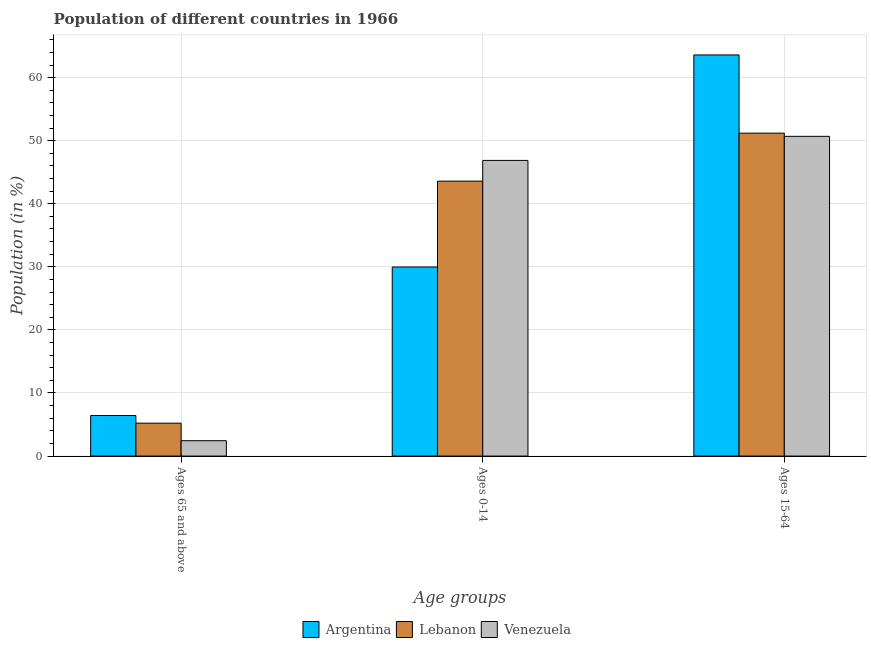How many different coloured bars are there?
Your answer should be very brief. 3. How many groups of bars are there?
Provide a succinct answer. 3. Are the number of bars per tick equal to the number of legend labels?
Give a very brief answer. Yes. What is the label of the 1st group of bars from the left?
Ensure brevity in your answer.  Ages 65 and above. What is the percentage of population within the age-group 0-14 in Venezuela?
Provide a succinct answer. 46.87. Across all countries, what is the maximum percentage of population within the age-group of 65 and above?
Your answer should be compact. 6.43. Across all countries, what is the minimum percentage of population within the age-group 0-14?
Your response must be concise. 29.98. In which country was the percentage of population within the age-group 15-64 minimum?
Your answer should be compact. Venezuela. What is the total percentage of population within the age-group of 65 and above in the graph?
Your answer should be very brief. 14.08. What is the difference between the percentage of population within the age-group of 65 and above in Argentina and that in Venezuela?
Offer a terse response. 3.99. What is the difference between the percentage of population within the age-group of 65 and above in Argentina and the percentage of population within the age-group 0-14 in Venezuela?
Ensure brevity in your answer.  -40.44. What is the average percentage of population within the age-group of 65 and above per country?
Ensure brevity in your answer.  4.69. What is the difference between the percentage of population within the age-group 15-64 and percentage of population within the age-group 0-14 in Argentina?
Your answer should be very brief. 33.62. In how many countries, is the percentage of population within the age-group 15-64 greater than 64 %?
Your answer should be very brief. 0. What is the ratio of the percentage of population within the age-group of 65 and above in Venezuela to that in Argentina?
Provide a succinct answer. 0.38. What is the difference between the highest and the second highest percentage of population within the age-group 0-14?
Ensure brevity in your answer.  3.29. What is the difference between the highest and the lowest percentage of population within the age-group of 65 and above?
Provide a succinct answer. 3.99. In how many countries, is the percentage of population within the age-group 15-64 greater than the average percentage of population within the age-group 15-64 taken over all countries?
Offer a terse response. 1. Is the sum of the percentage of population within the age-group 15-64 in Argentina and Lebanon greater than the maximum percentage of population within the age-group of 65 and above across all countries?
Give a very brief answer. Yes. What does the 2nd bar from the right in Ages 65 and above represents?
Offer a terse response. Lebanon. Are the values on the major ticks of Y-axis written in scientific E-notation?
Give a very brief answer. No. Where does the legend appear in the graph?
Provide a succinct answer. Bottom center. How many legend labels are there?
Your response must be concise. 3. How are the legend labels stacked?
Your response must be concise. Horizontal. What is the title of the graph?
Keep it short and to the point. Population of different countries in 1966. What is the label or title of the X-axis?
Your answer should be compact. Age groups. What is the label or title of the Y-axis?
Offer a very short reply. Population (in %). What is the Population (in %) in Argentina in Ages 65 and above?
Make the answer very short. 6.43. What is the Population (in %) in Lebanon in Ages 65 and above?
Make the answer very short. 5.22. What is the Population (in %) in Venezuela in Ages 65 and above?
Your response must be concise. 2.44. What is the Population (in %) in Argentina in Ages 0-14?
Your answer should be very brief. 29.98. What is the Population (in %) of Lebanon in Ages 0-14?
Provide a short and direct response. 43.59. What is the Population (in %) of Venezuela in Ages 0-14?
Your response must be concise. 46.87. What is the Population (in %) of Argentina in Ages 15-64?
Offer a very short reply. 63.6. What is the Population (in %) of Lebanon in Ages 15-64?
Provide a short and direct response. 51.2. What is the Population (in %) in Venezuela in Ages 15-64?
Make the answer very short. 50.69. Across all Age groups, what is the maximum Population (in %) in Argentina?
Ensure brevity in your answer.  63.6. Across all Age groups, what is the maximum Population (in %) in Lebanon?
Your response must be concise. 51.2. Across all Age groups, what is the maximum Population (in %) in Venezuela?
Your answer should be compact. 50.69. Across all Age groups, what is the minimum Population (in %) in Argentina?
Your answer should be very brief. 6.43. Across all Age groups, what is the minimum Population (in %) in Lebanon?
Your answer should be very brief. 5.22. Across all Age groups, what is the minimum Population (in %) of Venezuela?
Your response must be concise. 2.44. What is the total Population (in %) of Lebanon in the graph?
Your answer should be compact. 100. What is the total Population (in %) of Venezuela in the graph?
Provide a succinct answer. 100. What is the difference between the Population (in %) in Argentina in Ages 65 and above and that in Ages 0-14?
Offer a very short reply. -23.55. What is the difference between the Population (in %) of Lebanon in Ages 65 and above and that in Ages 0-14?
Ensure brevity in your answer.  -38.37. What is the difference between the Population (in %) of Venezuela in Ages 65 and above and that in Ages 0-14?
Make the answer very short. -44.44. What is the difference between the Population (in %) of Argentina in Ages 65 and above and that in Ages 15-64?
Your response must be concise. -57.17. What is the difference between the Population (in %) of Lebanon in Ages 65 and above and that in Ages 15-64?
Offer a very short reply. -45.98. What is the difference between the Population (in %) in Venezuela in Ages 65 and above and that in Ages 15-64?
Offer a very short reply. -48.25. What is the difference between the Population (in %) of Argentina in Ages 0-14 and that in Ages 15-64?
Offer a terse response. -33.62. What is the difference between the Population (in %) of Lebanon in Ages 0-14 and that in Ages 15-64?
Offer a terse response. -7.61. What is the difference between the Population (in %) in Venezuela in Ages 0-14 and that in Ages 15-64?
Keep it short and to the point. -3.82. What is the difference between the Population (in %) of Argentina in Ages 65 and above and the Population (in %) of Lebanon in Ages 0-14?
Your answer should be compact. -37.16. What is the difference between the Population (in %) in Argentina in Ages 65 and above and the Population (in %) in Venezuela in Ages 0-14?
Offer a very short reply. -40.44. What is the difference between the Population (in %) of Lebanon in Ages 65 and above and the Population (in %) of Venezuela in Ages 0-14?
Ensure brevity in your answer.  -41.65. What is the difference between the Population (in %) in Argentina in Ages 65 and above and the Population (in %) in Lebanon in Ages 15-64?
Offer a terse response. -44.77. What is the difference between the Population (in %) of Argentina in Ages 65 and above and the Population (in %) of Venezuela in Ages 15-64?
Offer a terse response. -44.26. What is the difference between the Population (in %) of Lebanon in Ages 65 and above and the Population (in %) of Venezuela in Ages 15-64?
Make the answer very short. -45.47. What is the difference between the Population (in %) of Argentina in Ages 0-14 and the Population (in %) of Lebanon in Ages 15-64?
Your answer should be compact. -21.22. What is the difference between the Population (in %) of Argentina in Ages 0-14 and the Population (in %) of Venezuela in Ages 15-64?
Make the answer very short. -20.71. What is the difference between the Population (in %) of Lebanon in Ages 0-14 and the Population (in %) of Venezuela in Ages 15-64?
Give a very brief answer. -7.11. What is the average Population (in %) of Argentina per Age groups?
Your answer should be compact. 33.33. What is the average Population (in %) of Lebanon per Age groups?
Your answer should be very brief. 33.33. What is the average Population (in %) of Venezuela per Age groups?
Make the answer very short. 33.33. What is the difference between the Population (in %) of Argentina and Population (in %) of Lebanon in Ages 65 and above?
Provide a succinct answer. 1.21. What is the difference between the Population (in %) of Argentina and Population (in %) of Venezuela in Ages 65 and above?
Offer a terse response. 3.99. What is the difference between the Population (in %) of Lebanon and Population (in %) of Venezuela in Ages 65 and above?
Offer a very short reply. 2.78. What is the difference between the Population (in %) in Argentina and Population (in %) in Lebanon in Ages 0-14?
Offer a very short reply. -13.61. What is the difference between the Population (in %) of Argentina and Population (in %) of Venezuela in Ages 0-14?
Ensure brevity in your answer.  -16.9. What is the difference between the Population (in %) of Lebanon and Population (in %) of Venezuela in Ages 0-14?
Provide a short and direct response. -3.29. What is the difference between the Population (in %) in Argentina and Population (in %) in Lebanon in Ages 15-64?
Make the answer very short. 12.4. What is the difference between the Population (in %) of Argentina and Population (in %) of Venezuela in Ages 15-64?
Offer a terse response. 12.91. What is the difference between the Population (in %) in Lebanon and Population (in %) in Venezuela in Ages 15-64?
Your response must be concise. 0.51. What is the ratio of the Population (in %) in Argentina in Ages 65 and above to that in Ages 0-14?
Provide a succinct answer. 0.21. What is the ratio of the Population (in %) in Lebanon in Ages 65 and above to that in Ages 0-14?
Ensure brevity in your answer.  0.12. What is the ratio of the Population (in %) of Venezuela in Ages 65 and above to that in Ages 0-14?
Provide a succinct answer. 0.05. What is the ratio of the Population (in %) in Argentina in Ages 65 and above to that in Ages 15-64?
Keep it short and to the point. 0.1. What is the ratio of the Population (in %) in Lebanon in Ages 65 and above to that in Ages 15-64?
Offer a very short reply. 0.1. What is the ratio of the Population (in %) in Venezuela in Ages 65 and above to that in Ages 15-64?
Your answer should be compact. 0.05. What is the ratio of the Population (in %) of Argentina in Ages 0-14 to that in Ages 15-64?
Offer a very short reply. 0.47. What is the ratio of the Population (in %) in Lebanon in Ages 0-14 to that in Ages 15-64?
Provide a short and direct response. 0.85. What is the ratio of the Population (in %) in Venezuela in Ages 0-14 to that in Ages 15-64?
Your answer should be very brief. 0.92. What is the difference between the highest and the second highest Population (in %) of Argentina?
Give a very brief answer. 33.62. What is the difference between the highest and the second highest Population (in %) in Lebanon?
Offer a terse response. 7.61. What is the difference between the highest and the second highest Population (in %) of Venezuela?
Your response must be concise. 3.82. What is the difference between the highest and the lowest Population (in %) in Argentina?
Your response must be concise. 57.17. What is the difference between the highest and the lowest Population (in %) of Lebanon?
Keep it short and to the point. 45.98. What is the difference between the highest and the lowest Population (in %) of Venezuela?
Your answer should be very brief. 48.25. 